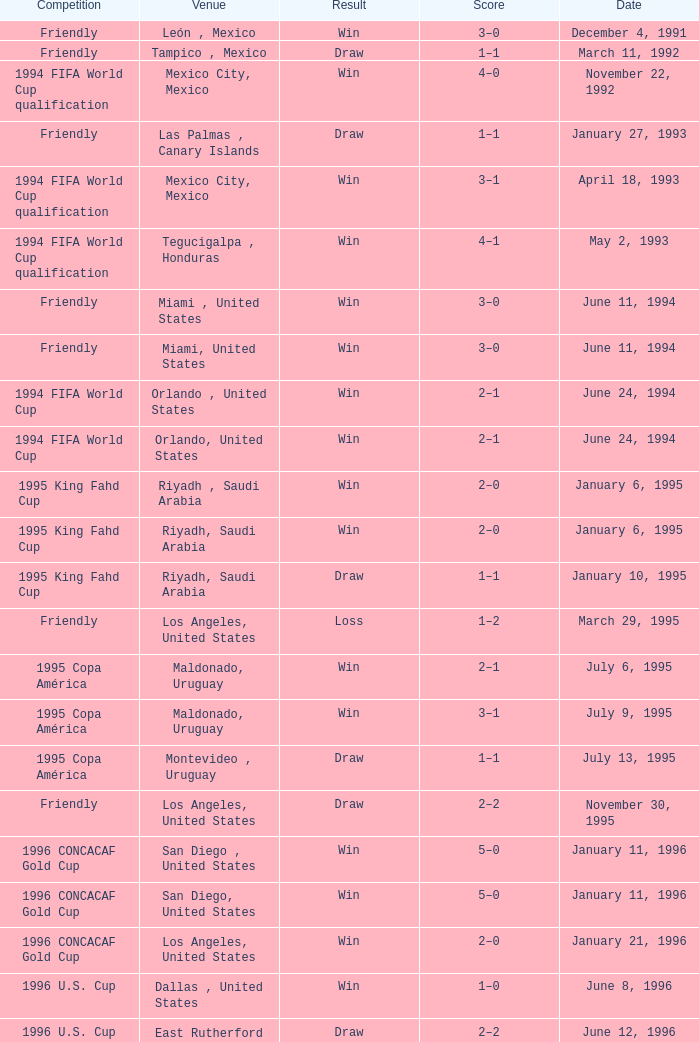What is Venue, when Date is "January 6, 1995"? Riyadh , Saudi Arabia, Riyadh, Saudi Arabia. 